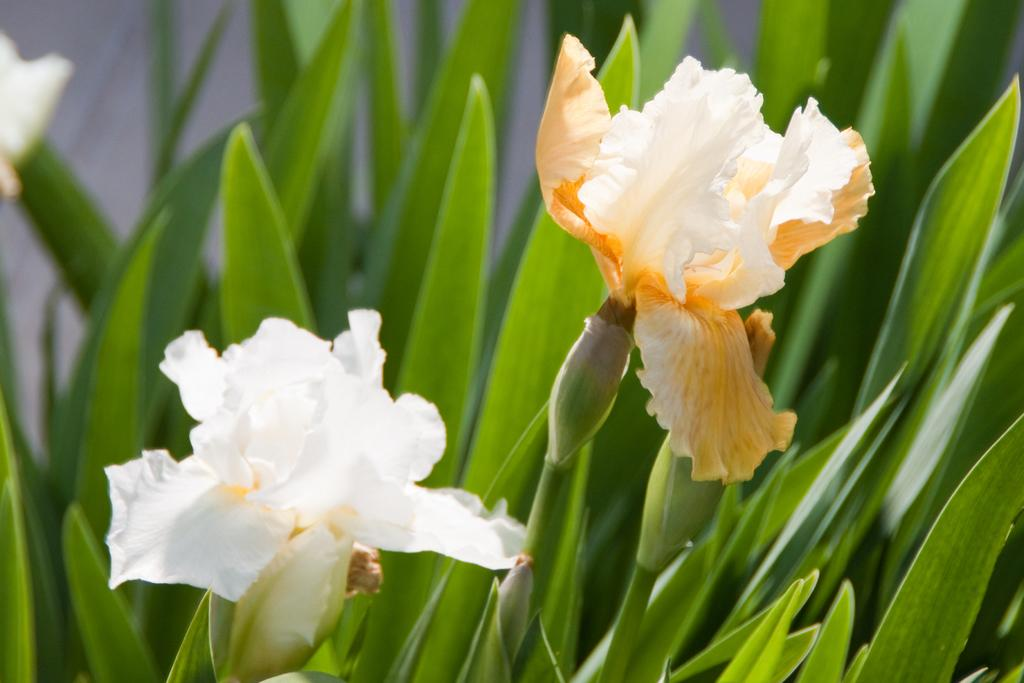What type of living organisms can be seen in the image? Plants can be seen in the image. Are there any specific features of the plants that are visible? Some of the plants have flowers. What can be seen in the background of the image? There are leaves of plants in the background. What is the color of the background in the image? The background is white in color. How many girls are holding the plants in the image? There are no girls present in the image; it only features plants. What type of ear can be seen on the plants in the image? There are no ears present in the image, as plants do not have ears. 